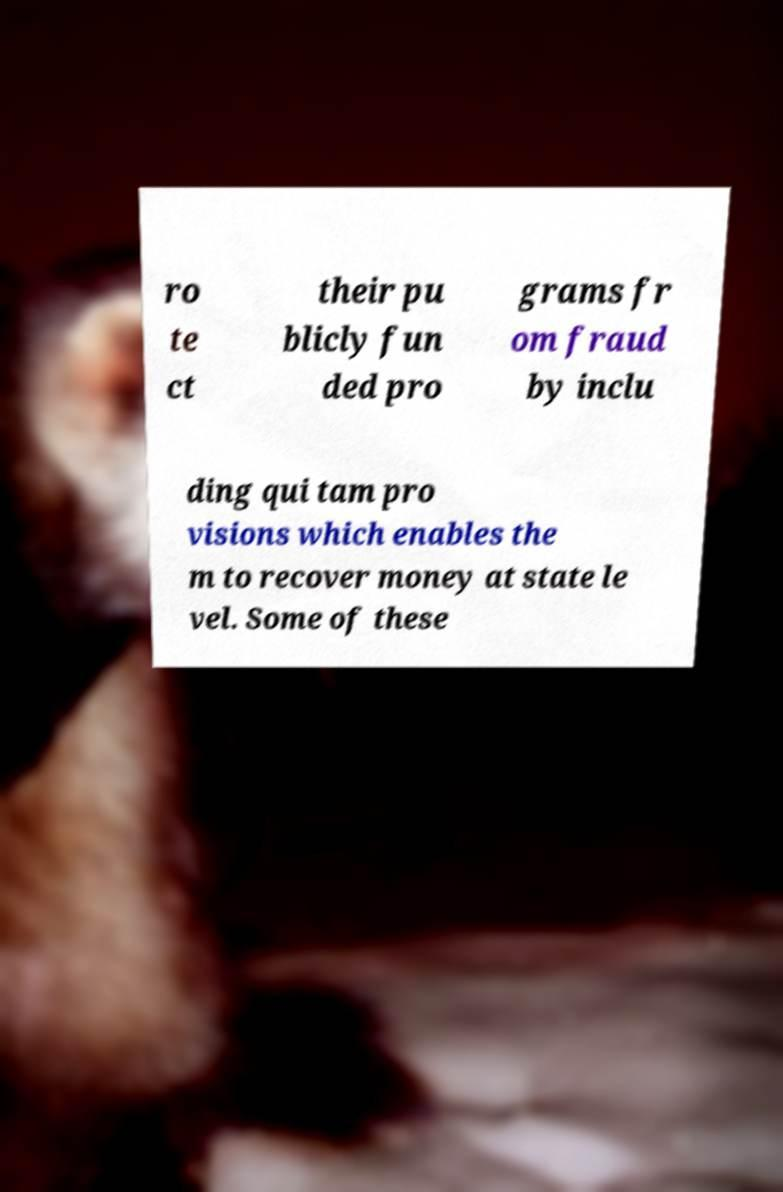Can you accurately transcribe the text from the provided image for me? ro te ct their pu blicly fun ded pro grams fr om fraud by inclu ding qui tam pro visions which enables the m to recover money at state le vel. Some of these 